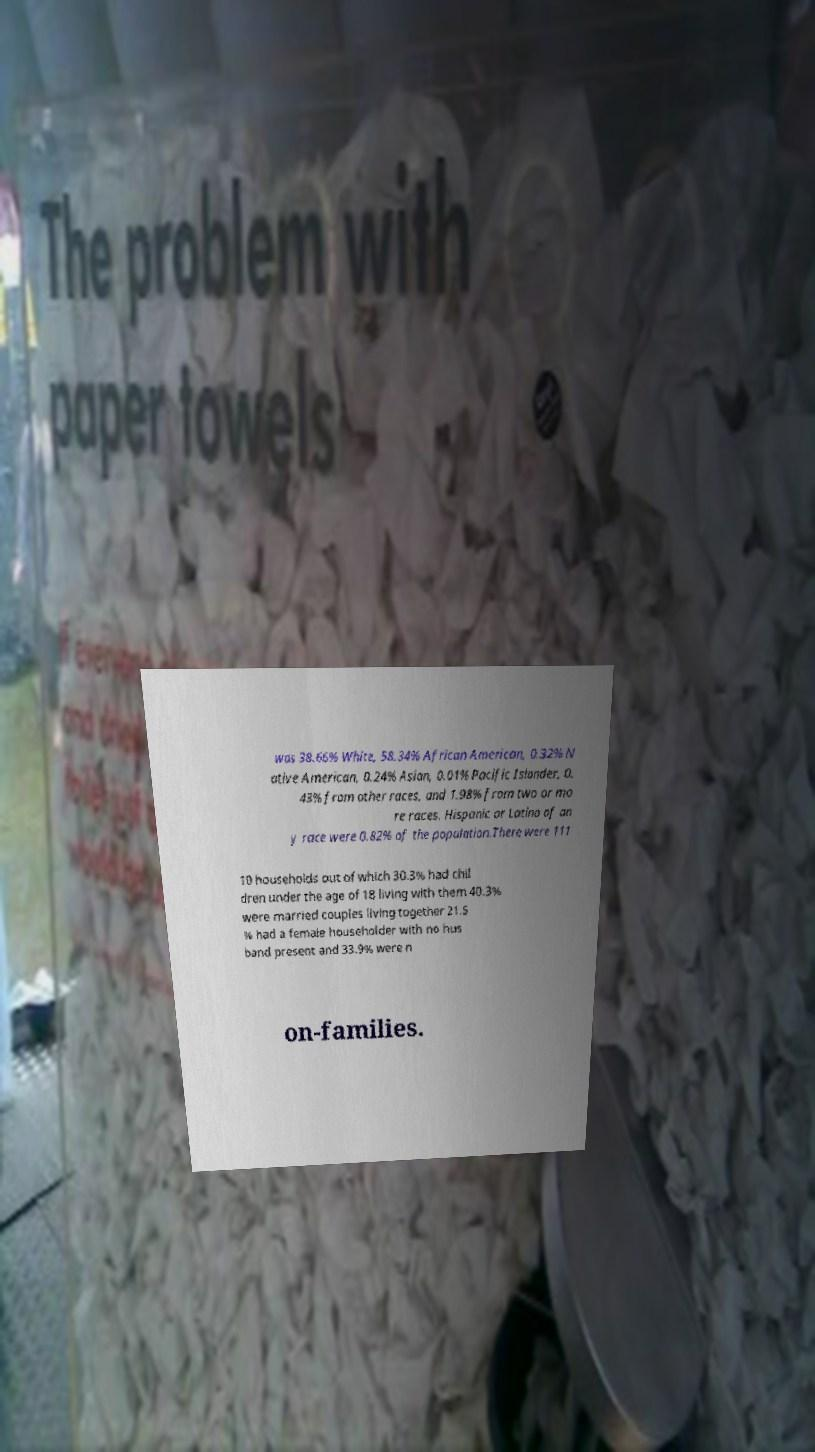What messages or text are displayed in this image? I need them in a readable, typed format. was 38.66% White, 58.34% African American, 0.32% N ative American, 0.24% Asian, 0.01% Pacific Islander, 0. 43% from other races, and 1.98% from two or mo re races. Hispanic or Latino of an y race were 0.82% of the population.There were 111 10 households out of which 30.3% had chil dren under the age of 18 living with them 40.3% were married couples living together 21.5 % had a female householder with no hus band present and 33.9% were n on-families. 